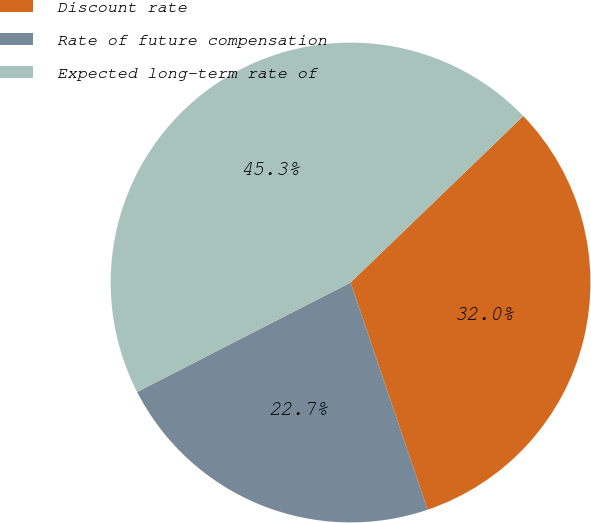Convert chart. <chart><loc_0><loc_0><loc_500><loc_500><pie_chart><fcel>Discount rate<fcel>Rate of future compensation<fcel>Expected long-term rate of<nl><fcel>32.01%<fcel>22.66%<fcel>45.33%<nl></chart> 